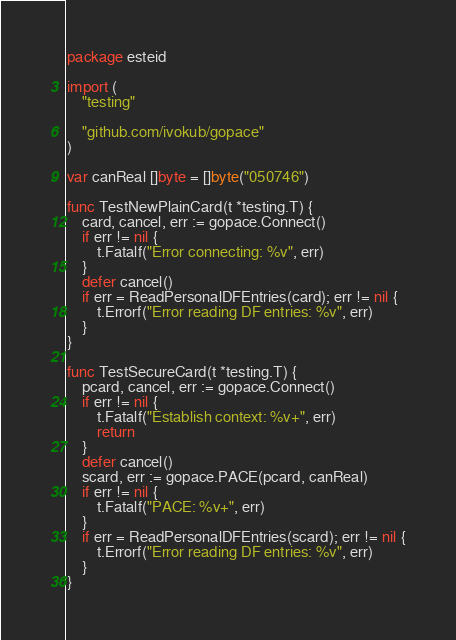Convert code to text. <code><loc_0><loc_0><loc_500><loc_500><_Go_>package esteid

import (
	"testing"

	"github.com/ivokub/gopace"
)

var canReal []byte = []byte("050746")

func TestNewPlainCard(t *testing.T) {
	card, cancel, err := gopace.Connect()
	if err != nil {
		t.Fatalf("Error connecting: %v", err)
	}
	defer cancel()
	if err = ReadPersonalDFEntries(card); err != nil {
		t.Errorf("Error reading DF entries: %v", err)
	}
}

func TestSecureCard(t *testing.T) {
	pcard, cancel, err := gopace.Connect()
	if err != nil {
		t.Fatalf("Establish context: %v+", err)
		return
	}
	defer cancel()
	scard, err := gopace.PACE(pcard, canReal)
	if err != nil {
		t.Fatalf("PACE: %v+", err)
	}
	if err = ReadPersonalDFEntries(scard); err != nil {
		t.Errorf("Error reading DF entries: %v", err)
	}
}
</code> 